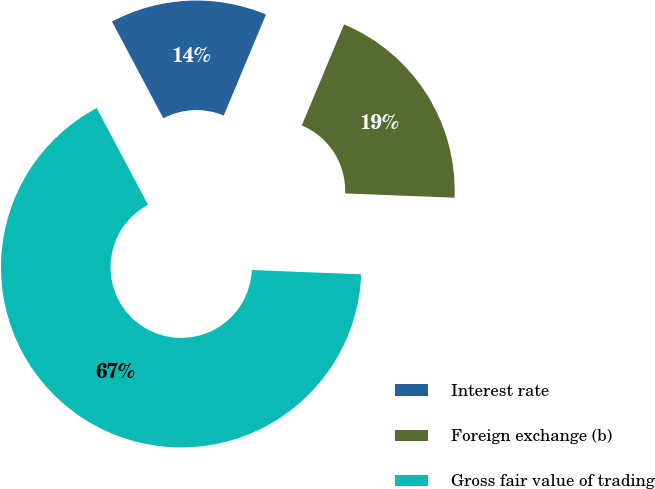Convert chart to OTSL. <chart><loc_0><loc_0><loc_500><loc_500><pie_chart><fcel>Interest rate<fcel>Foreign exchange (b)<fcel>Gross fair value of trading<nl><fcel>14.07%<fcel>19.32%<fcel>66.61%<nl></chart> 